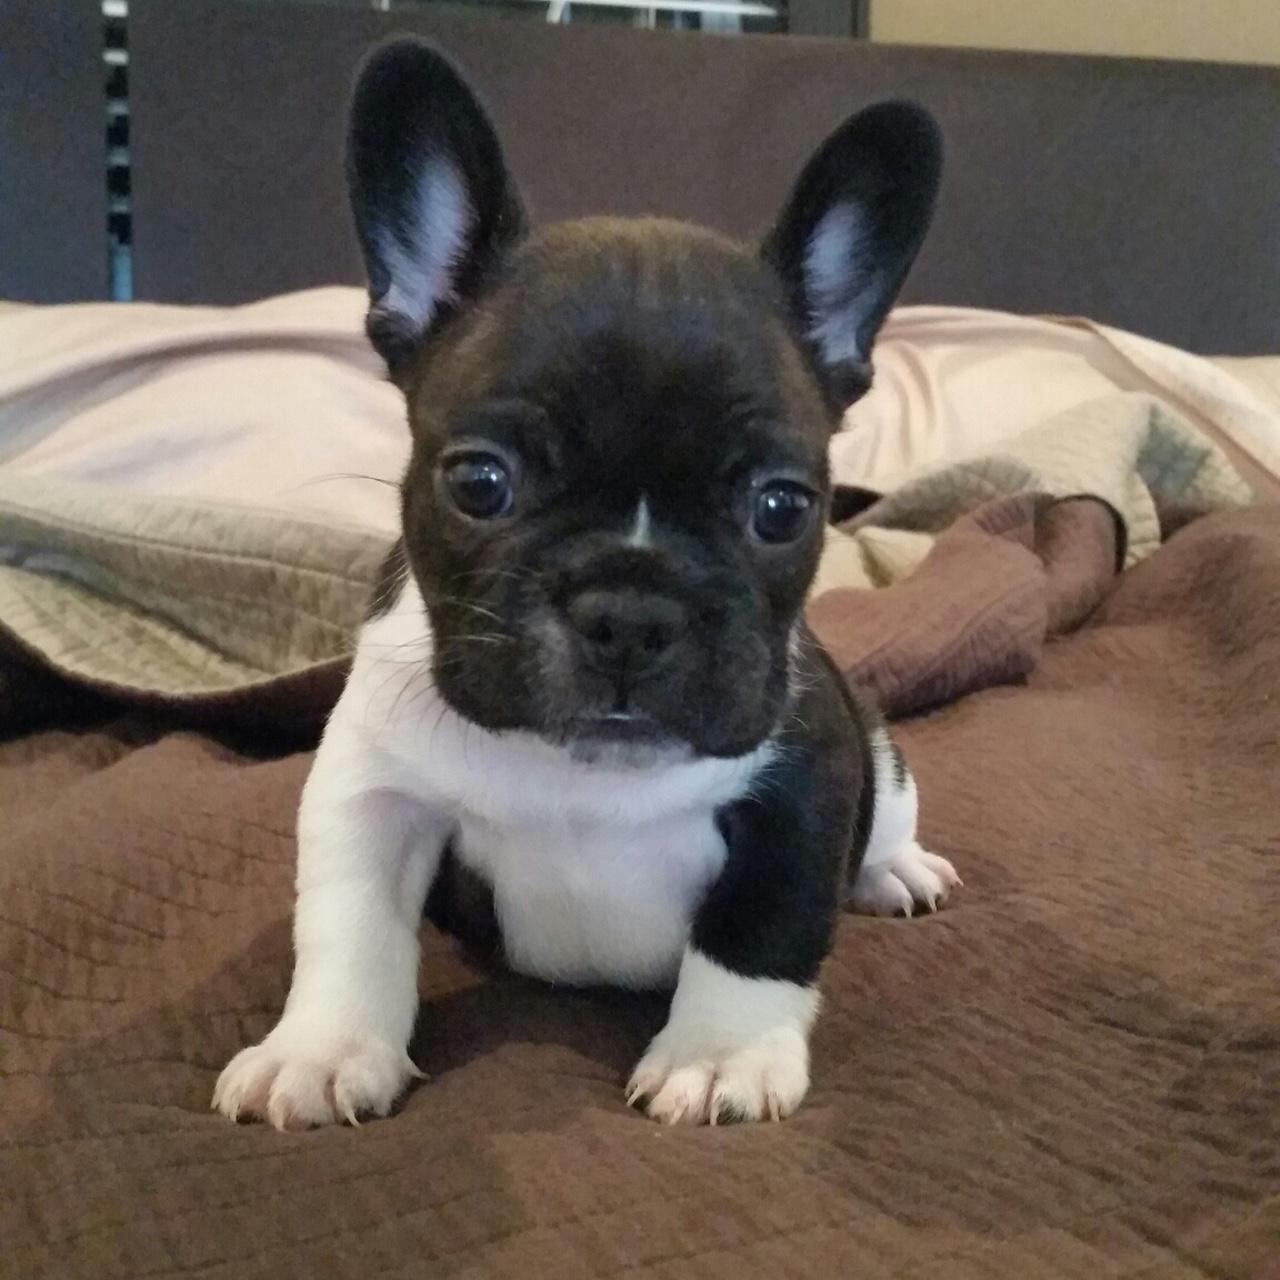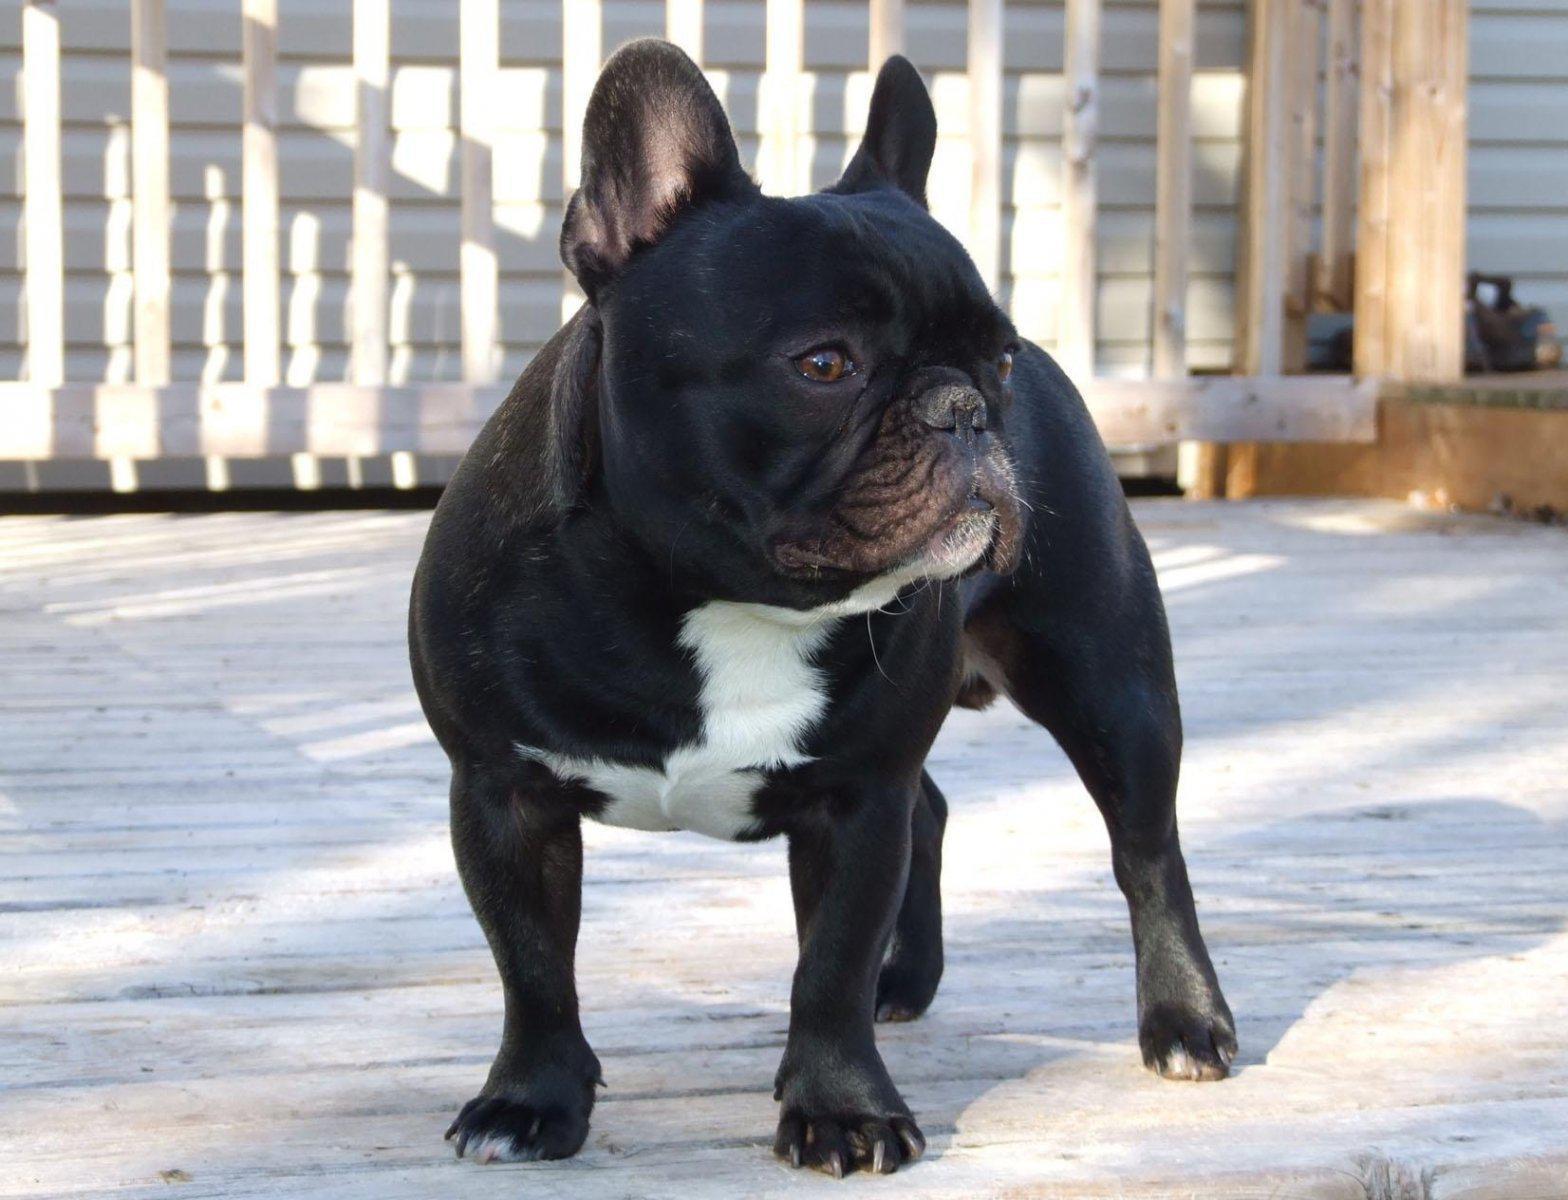The first image is the image on the left, the second image is the image on the right. Evaluate the accuracy of this statement regarding the images: "One image shows exactly two real puppies posed on a plush surface.". Is it true? Answer yes or no. No. The first image is the image on the left, the second image is the image on the right. Analyze the images presented: Is the assertion "There are exactly three dogs." valid? Answer yes or no. No. 